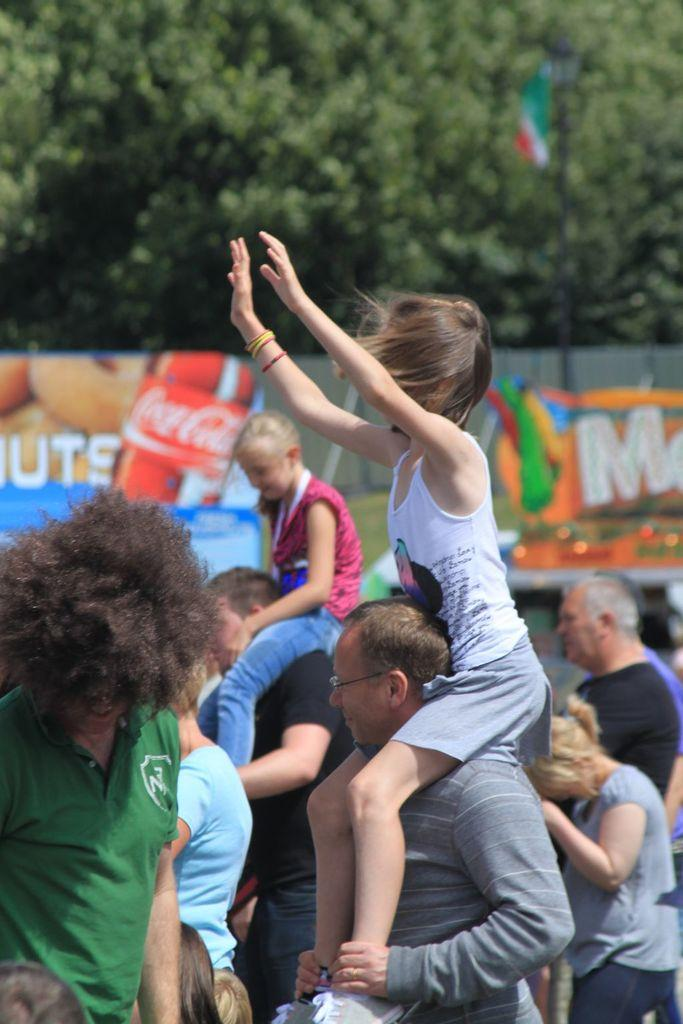How many people are present in the image? There are many people in the image. What can be seen in the background of the image? There are banners and trees in the background of the image. What is the flag attached to in the image? The flag is attached to a pole in the image. How many square rabbits can be seen hopping on the banners in the image? There are no rabbits, square or otherwise, present on the banners in the image. 